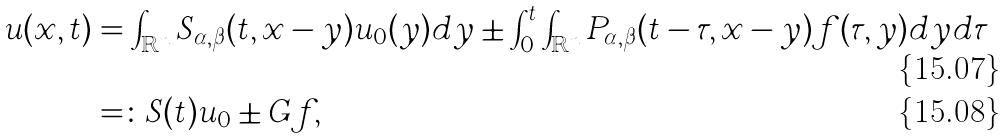Convert formula to latex. <formula><loc_0><loc_0><loc_500><loc_500>u ( x , t ) & = \int _ { \mathbb { R } ^ { n } } S _ { \alpha , \beta } ( t , x - y ) u _ { 0 } ( y ) d y \pm \int _ { 0 } ^ { t } \int _ { \mathbb { R } ^ { n } } P _ { \alpha , \beta } ( t - \tau , x - y ) f ( \tau , y ) d y d \tau \\ & = \colon S ( t ) u _ { 0 } \pm G f ,</formula> 